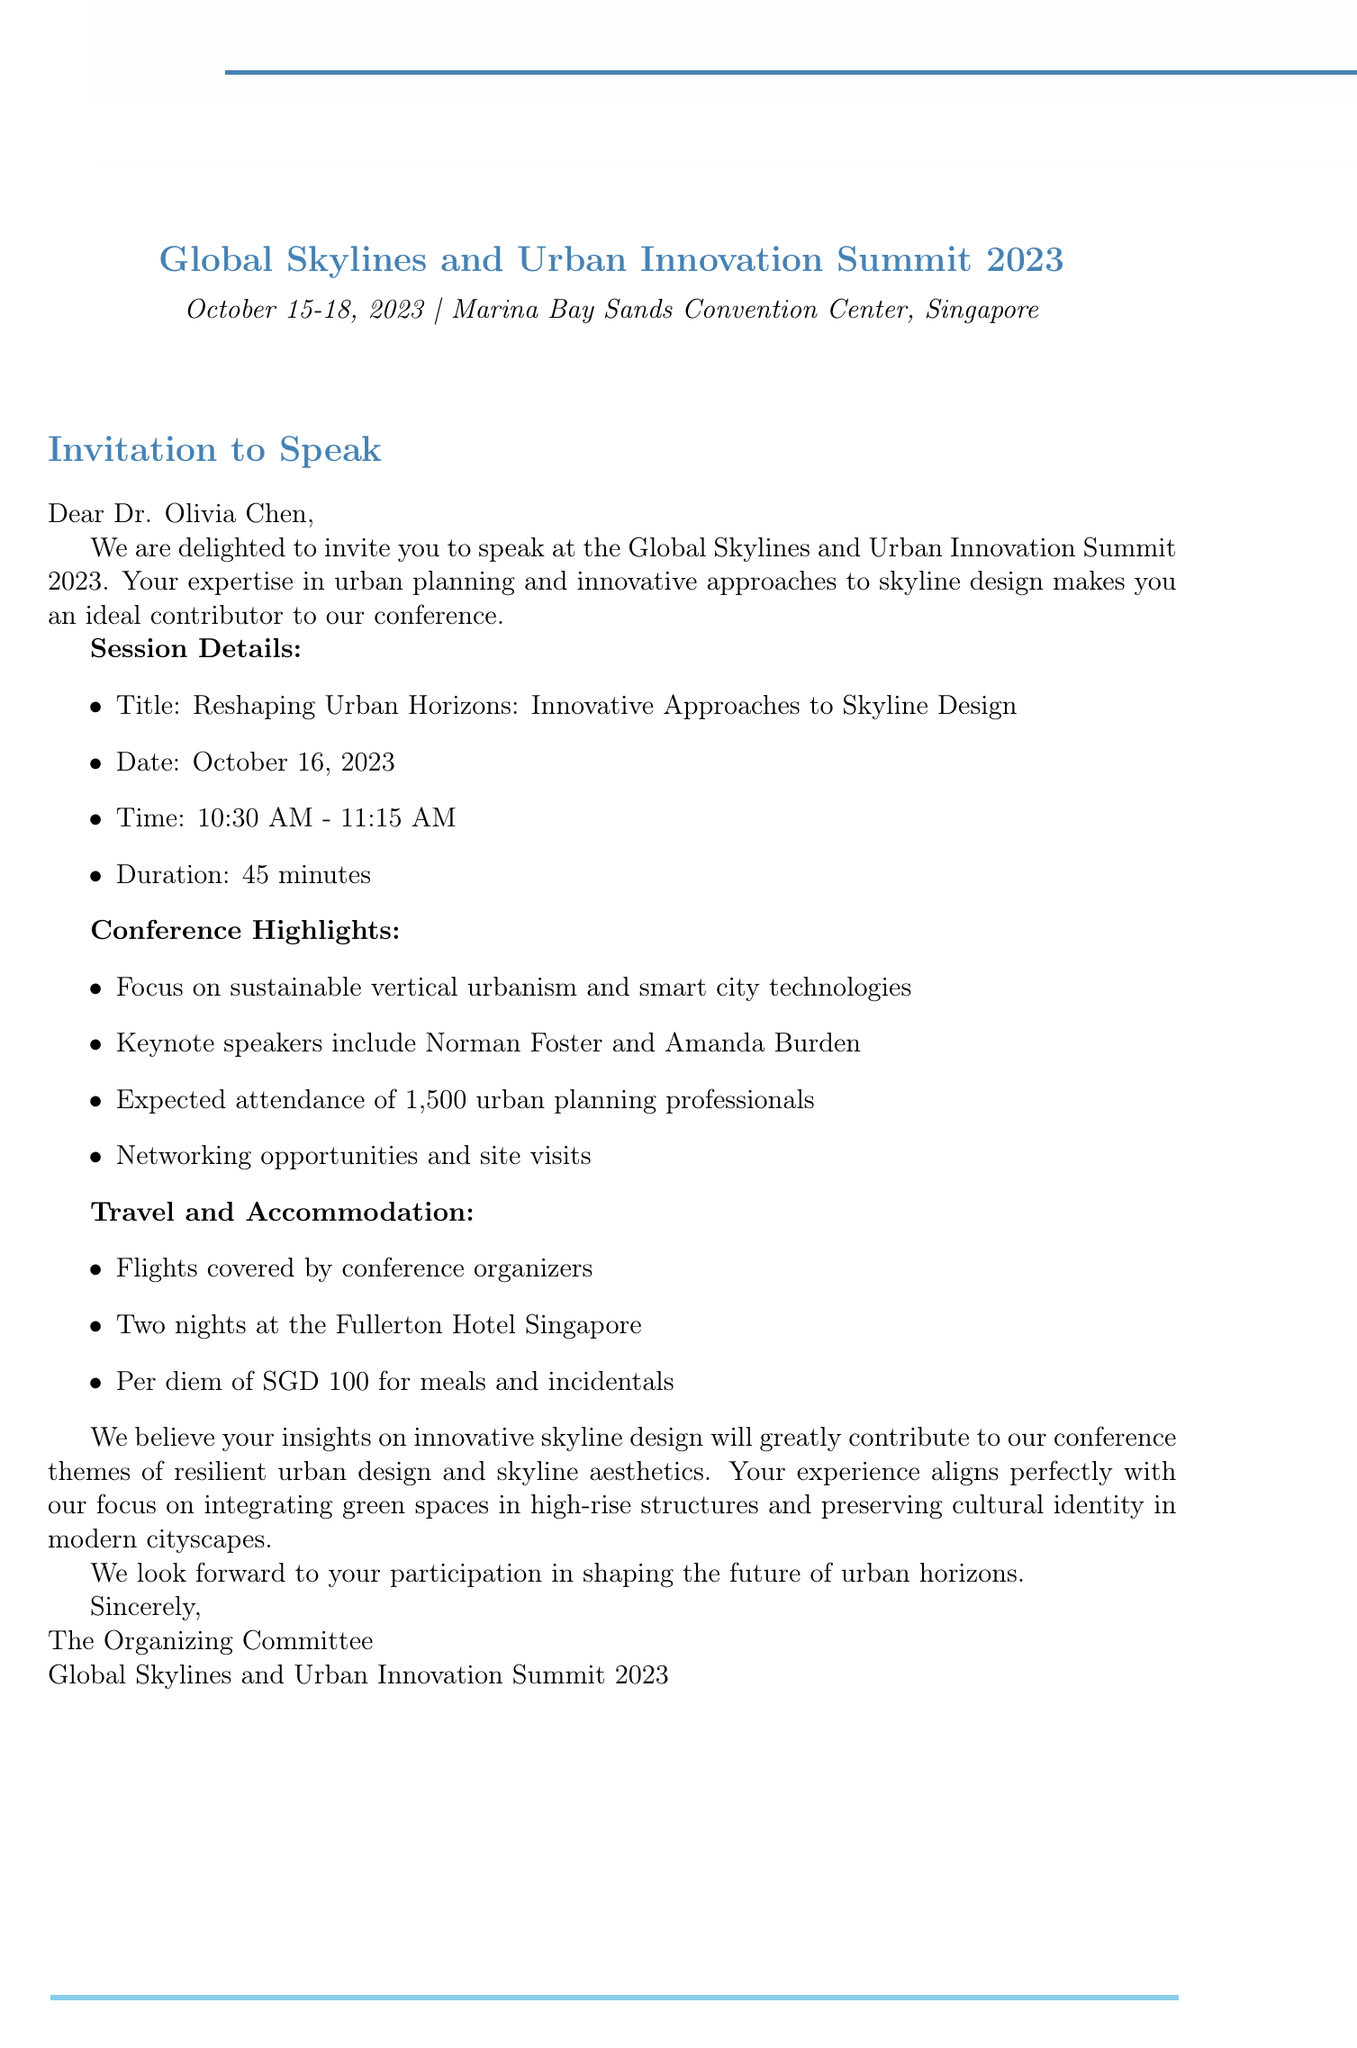What is the name of the conference? The name of the conference is clearly stated in the document as "Global Skylines and Urban Innovation Summit 2023".
Answer: Global Skylines and Urban Innovation Summit 2023 What are the dates of the conference? The document specifies that the conference will take place from October 15 to October 18, 2023.
Answer: October 15-18, 2023 Who is the invited speaker? The document mentions that the invited speaker is Dr. Olivia Chen.
Answer: Dr. Olivia Chen What is the session title? The title of the session is given as "Reshaping Urban Horizons: Innovative Approaches to Skyline Design".
Answer: Reshaping Urban Horizons: Innovative Approaches to Skyline Design How long is the session duration? The document states that the session duration is 45 minutes.
Answer: 45 minutes What are the expected total attendees? The document indicates an expected attendance of 1,500 professionals.
Answer: 1,500 What is covered for travel? The document mentions that the flights will be covered by the conference organizers.
Answer: Flights What is one key focus of the conference? The document highlights multiple focuses, and one of them is sustainable vertical urbanism.
Answer: Sustainable vertical urbanism What accommodation will be provided? The document states that two nights at the Fullerton Hotel Singapore will be arranged for the invited speaker.
Answer: Two nights at the Fullerton Hotel Singapore 